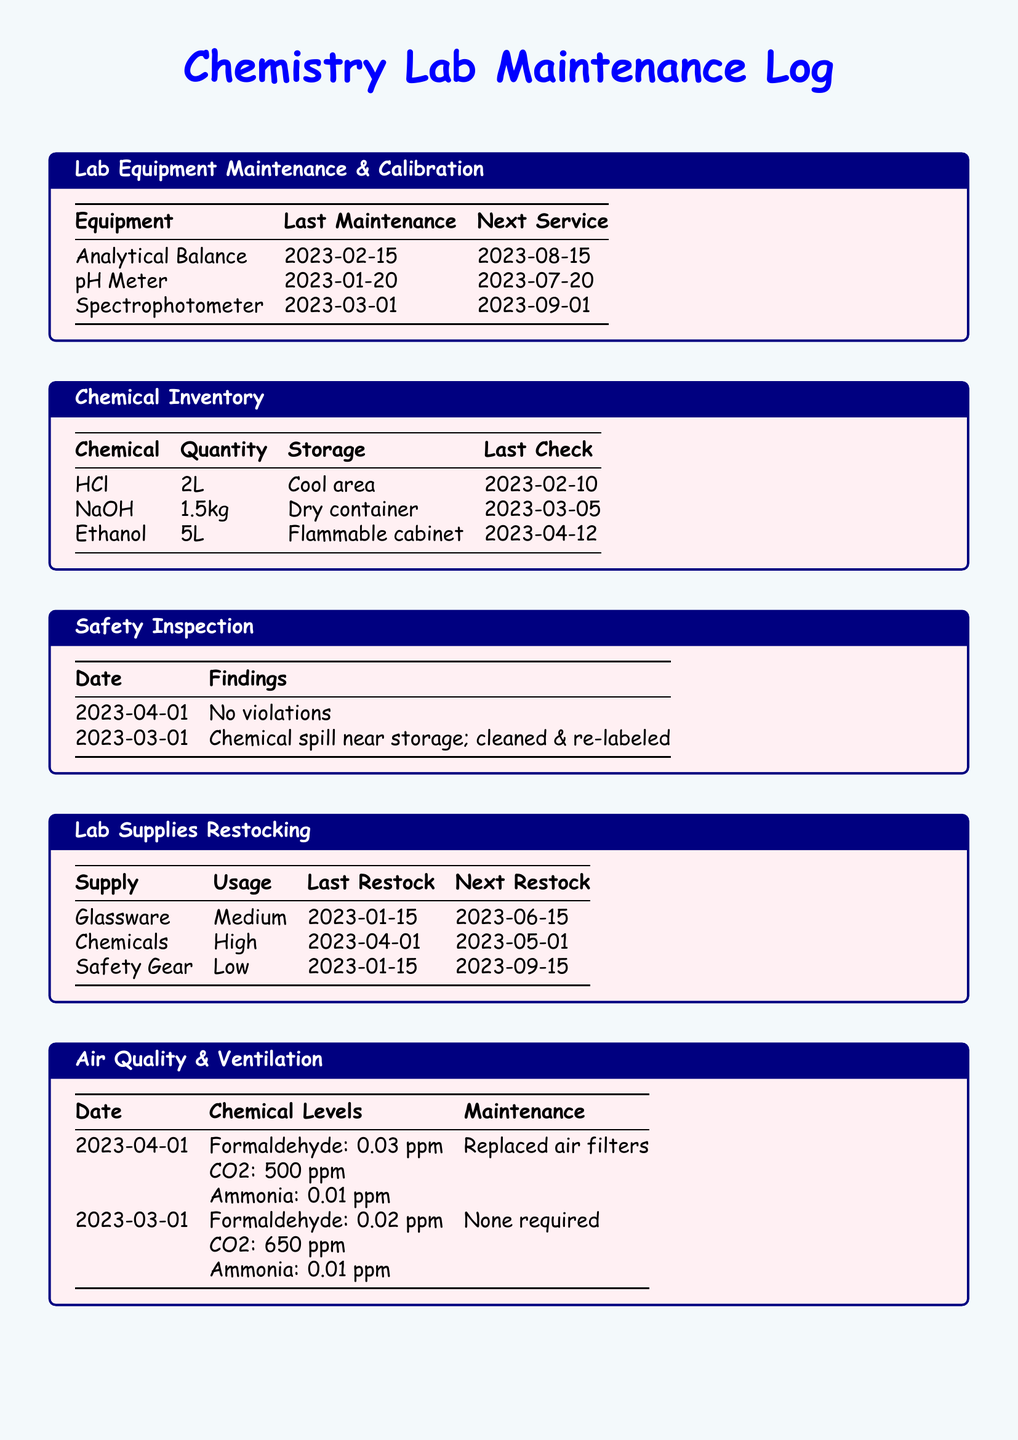what was the last maintenance date for the pH meter? The last maintenance date for the pH meter is explicitly stated in the maintenance log.
Answer: 2023-01-20 what chemical had the highest inventory quantity? By comparing the quantities listed in the chemical inventory, we can determine which chemical has the highest amount.
Answer: Ethanol when is the next restock date for chemicals? The next restock date for chemicals is noted in the lab supplies restocking section.
Answer: 2023-05-01 how many safety violations were found in the last inspection? The safety inspection summary states that during the last inspection on 2023-04-01, there were no violations.
Answer: 0 what maintenance was performed on the ventilation system on April 1, 2023? The maintenance section for air quality and ventilation specifies what was done on that date.
Answer: Replaced air filters what is the storage condition for NaOH? The document provides the storage conditions for each chemical, including NaOH.
Answer: Dry container what is the next service date for the spectrophotometer? The next service date for the spectrophotometer is mentioned in the maintenance log.
Answer: 2023-09-01 when was the last safety check performed? The date of the last safety inspection is recorded in the findings table of the document.
Answer: 2023-04-01 